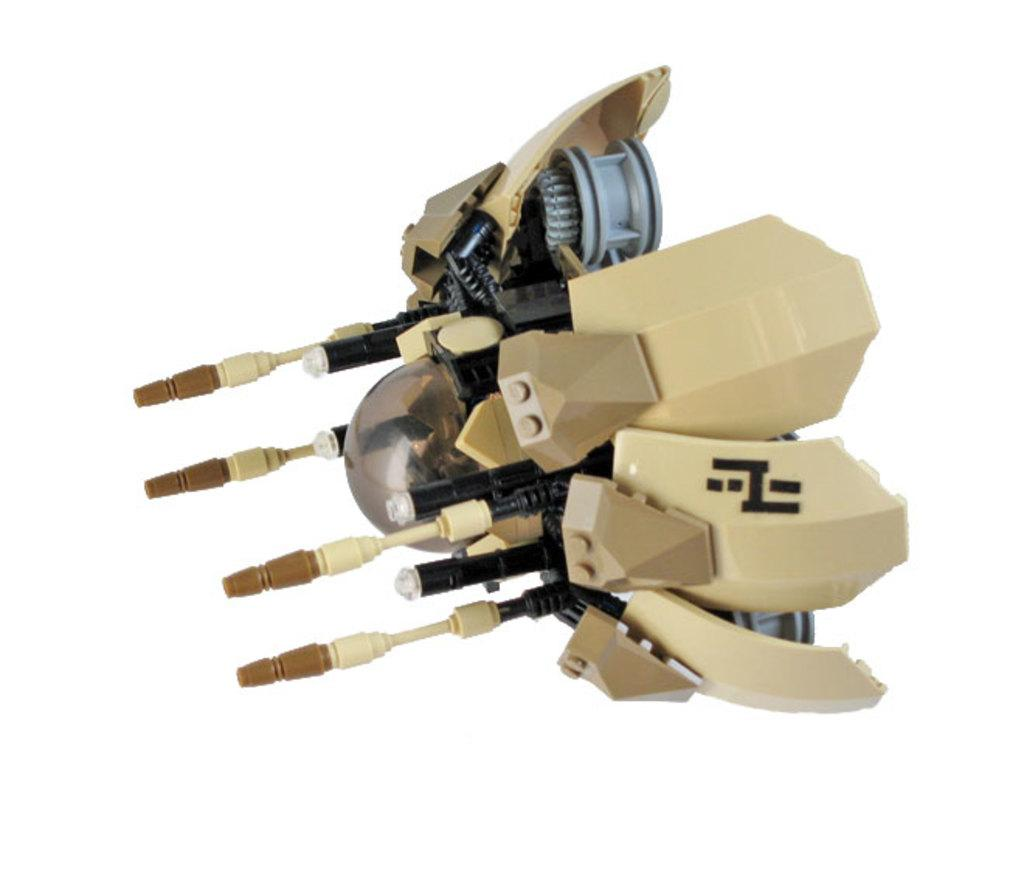What object can be seen in the image? There is a toy in the image. What material is the toy made of? The toy is made of plastic. What type of science experiment is being conducted in the image? There is no science experiment present in the image; it only features a plastic toy. What acoustics can be heard in the image? There is no sound or acoustics mentioned or depicted in the image, as it only shows a plastic toy. 